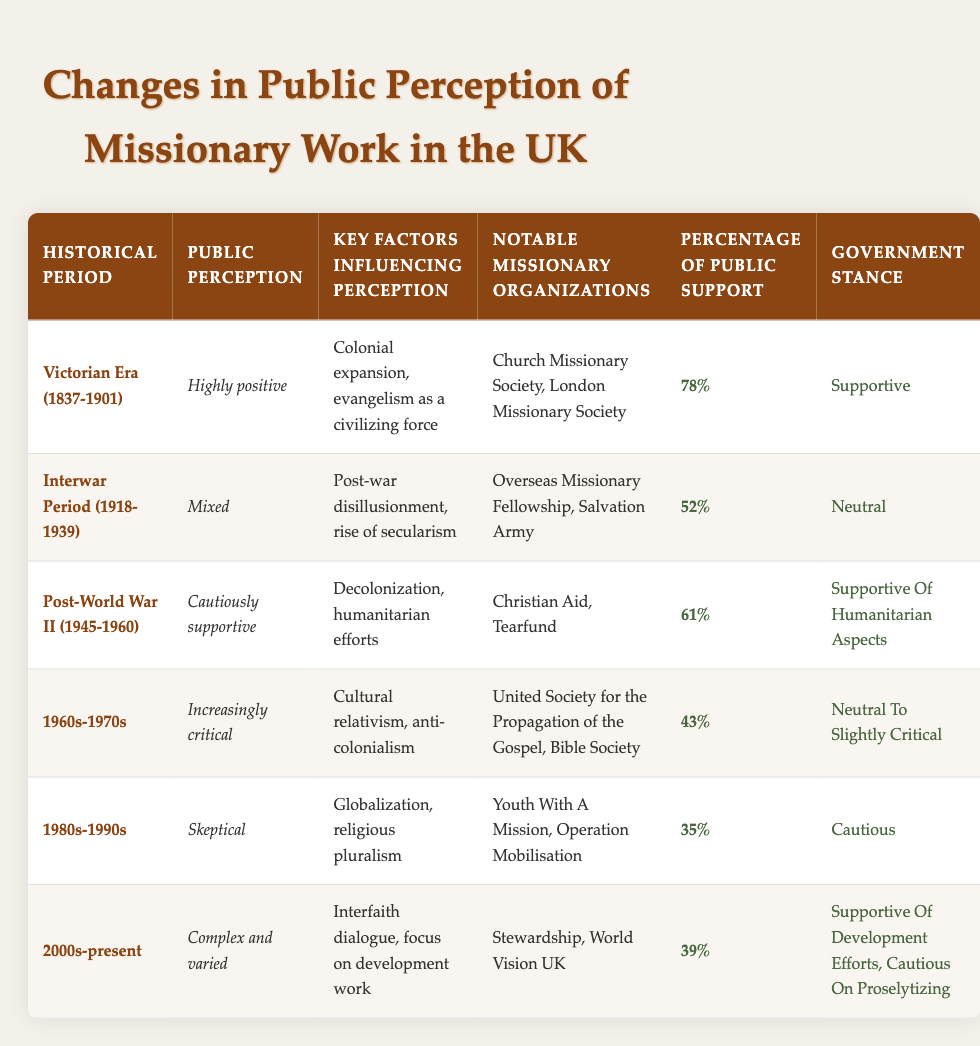What was the public perception of missionary work during the Victorian Era? The table states that the public perception during the Victorian Era (1837-1901) was "Highly positive."
Answer: Highly positive Which missionary organizations were notable during the Post-World War II period? According to the table, notable missionary organizations during the Post-World War II period (1945-1960) include Christian Aid and Tearfund.
Answer: Christian Aid, Tearfund What was the percentage of public support for missionary work in the 1960s-1970s? The table shows that the percentage of public support during the 1960s-1970s was 43%.
Answer: 43% Was the government stance during the Interwar Period supportive of missionary work? The table indicates that the government stance during the Interwar Period (1918-1939) was neutral, not supportive.
Answer: No What is the average percentage of public support across all periods listed in the table? The public support percentages are 78%, 52%, 61%, 43%, 35%, and 39%. First, we sum these values: 78 + 52 + 61 + 43 + 35 + 39 = 308. Then, we divide by the number of periods, which is 6: 308 / 6 = 51.33.
Answer: 51.33 How did public perception change from the Victorian Era to the 1980s-1990s? In the Victorian Era (1837-1901), public perception was highly positive, while during the 1980s-1990s, it was skeptical. This indicates a decline in positive perception over time.
Answer: Declined What were the key factors influencing public perception of missionary work during the 1980s-1990s? The table lists that during the 1980s-1990s, the key factors influencing perception were globalization and religious pluralism.
Answer: Globalization, religious pluralism During which historical period did public perception change to increasingly critical? The table states that public perception became increasingly critical during the 1960s-1970s.
Answer: 1960s-1970s 